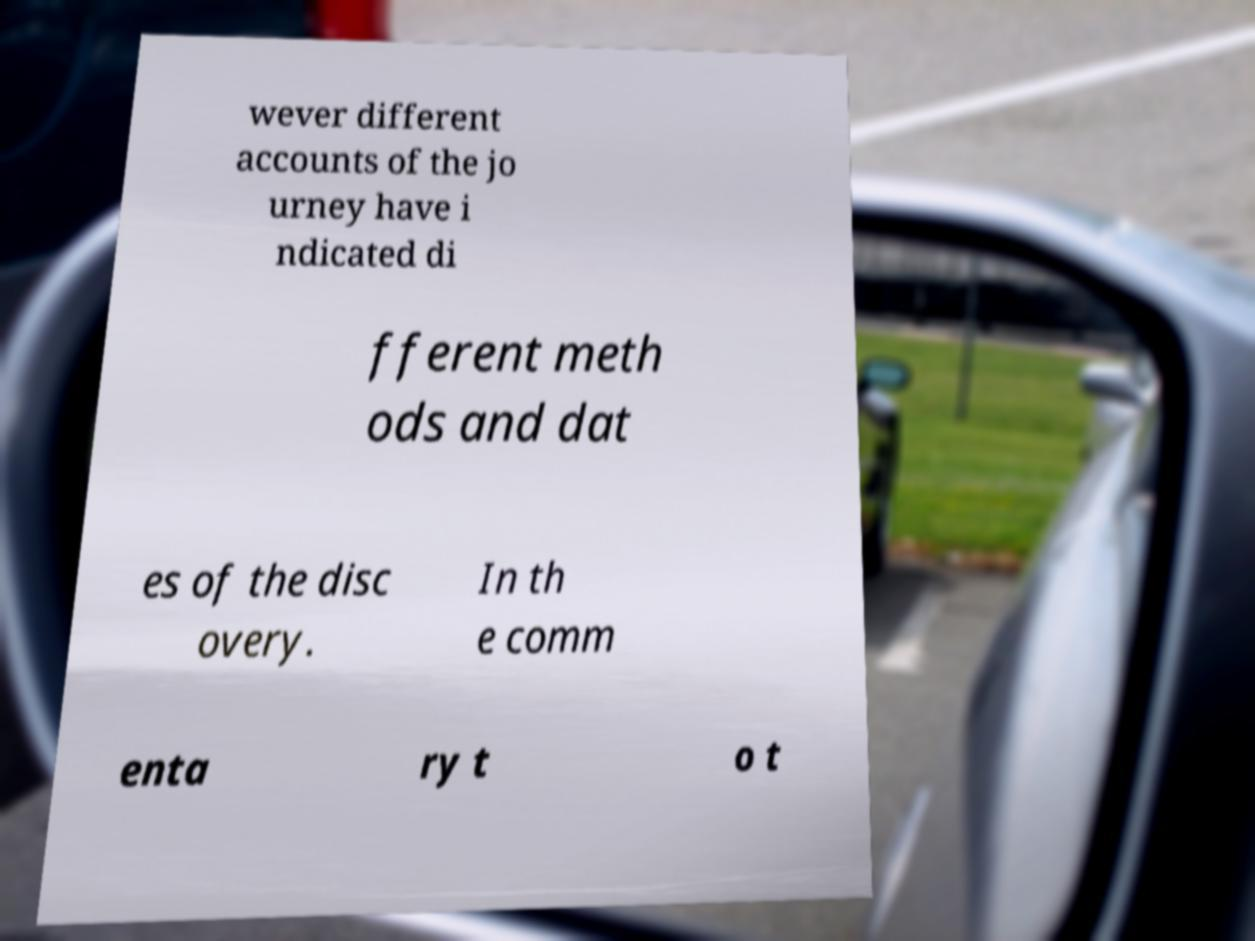There's text embedded in this image that I need extracted. Can you transcribe it verbatim? wever different accounts of the jo urney have i ndicated di fferent meth ods and dat es of the disc overy. In th e comm enta ry t o t 